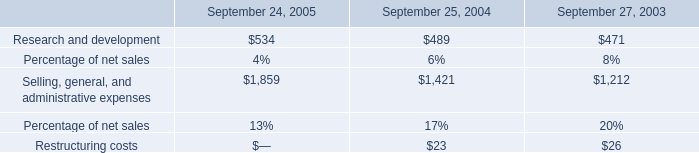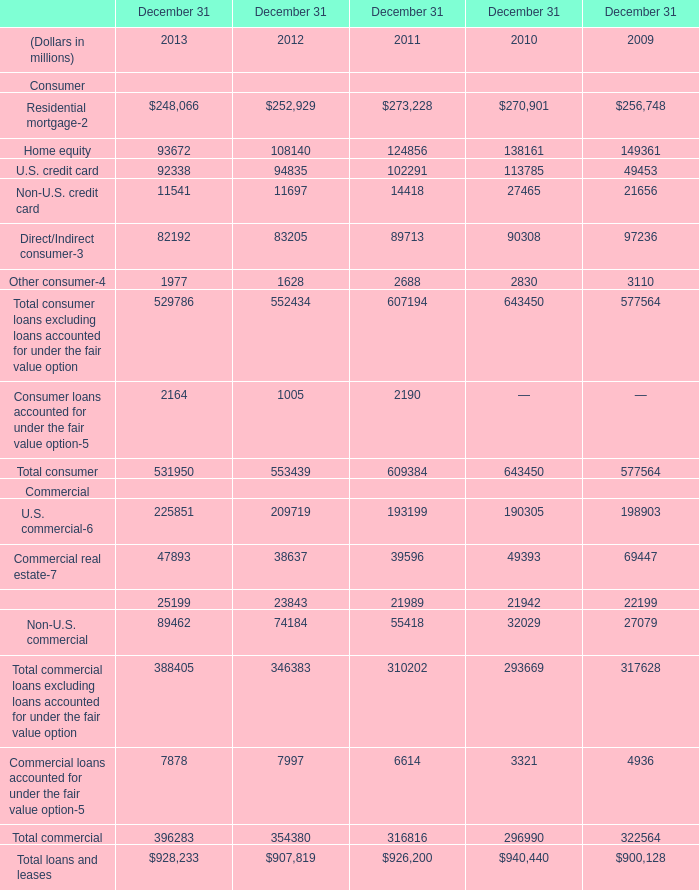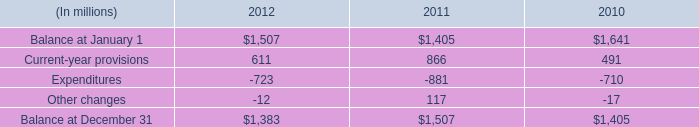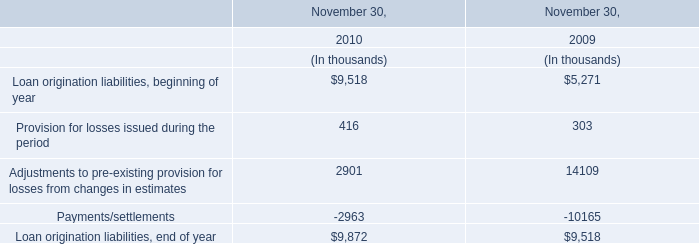What is the growing rate of Total consumer in the years with the least Home equity? 
Computations: ((531950 - 553439) / 553439)
Answer: -0.03883. 